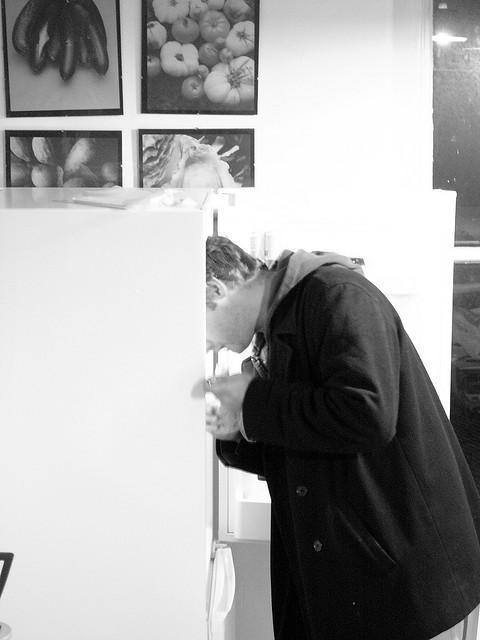How many pictures above the person's head?
Give a very brief answer. 4. 